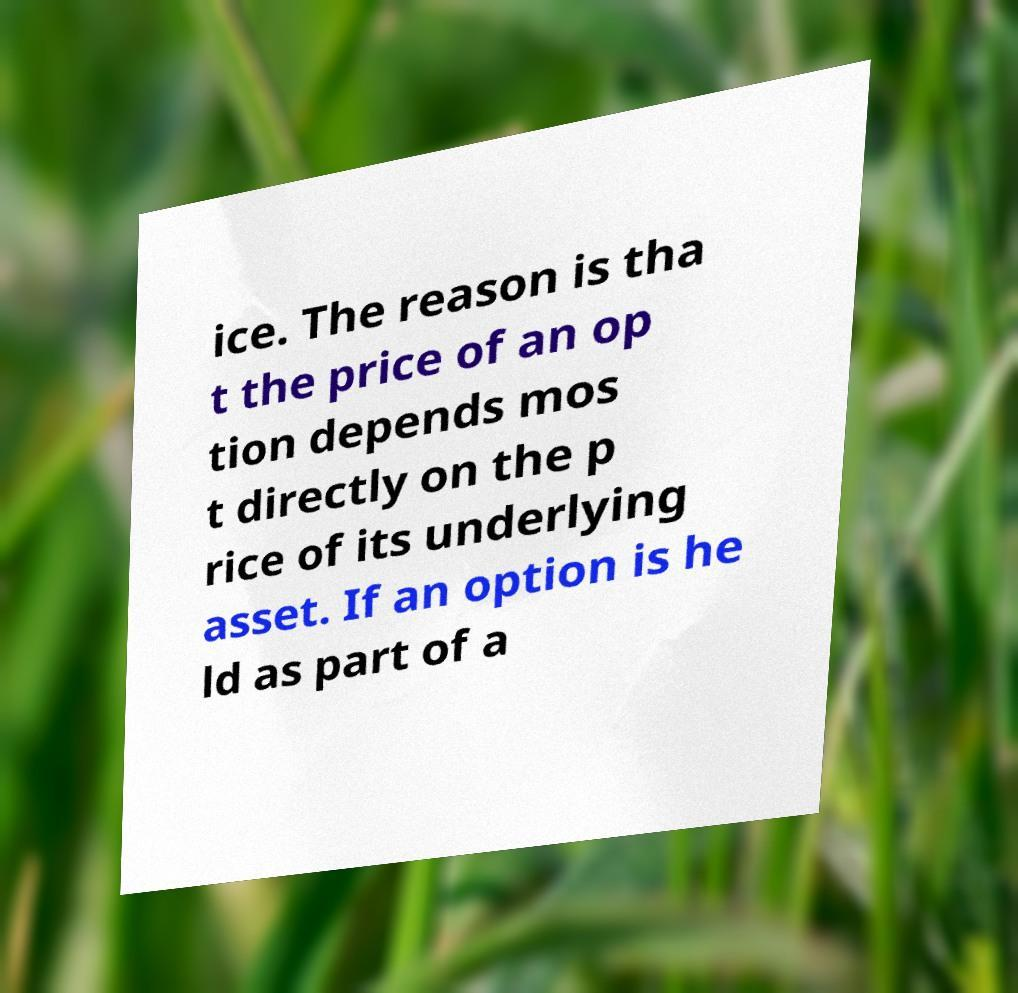What messages or text are displayed in this image? I need them in a readable, typed format. ice. The reason is tha t the price of an op tion depends mos t directly on the p rice of its underlying asset. If an option is he ld as part of a 